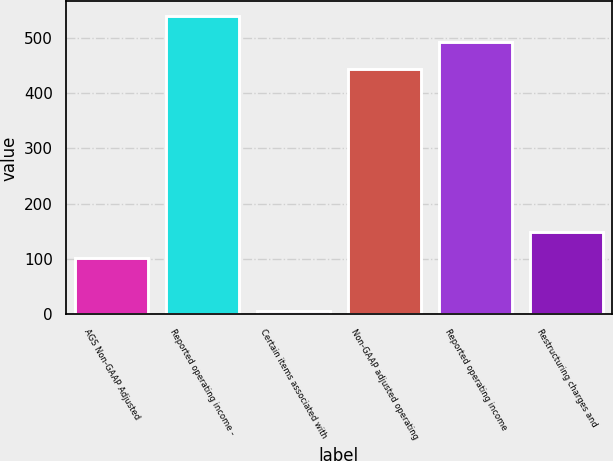<chart> <loc_0><loc_0><loc_500><loc_500><bar_chart><fcel>AGS Non-GAAP Adjusted<fcel>Reported operating income -<fcel>Certain items associated with<fcel>Non-GAAP adjusted operating<fcel>Reported operating income<fcel>Restructuring charges and<nl><fcel>102<fcel>539<fcel>7<fcel>444<fcel>491.5<fcel>149.5<nl></chart> 